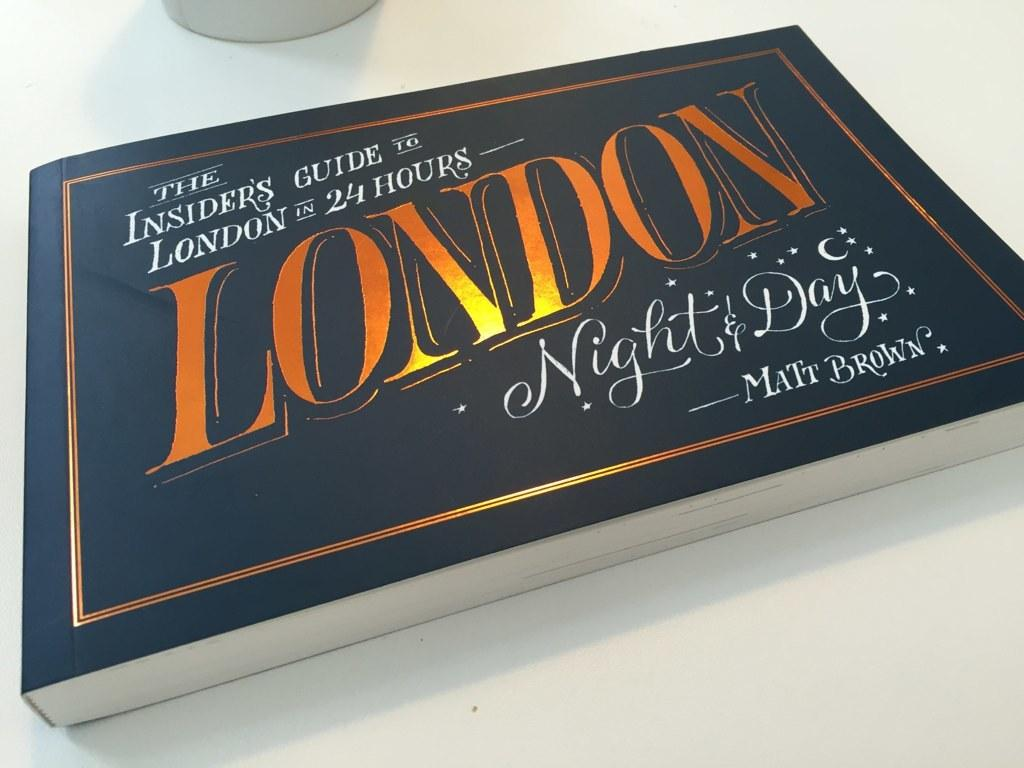<image>
Summarize the visual content of the image. A travel guide for The Insiders Guide to London. 